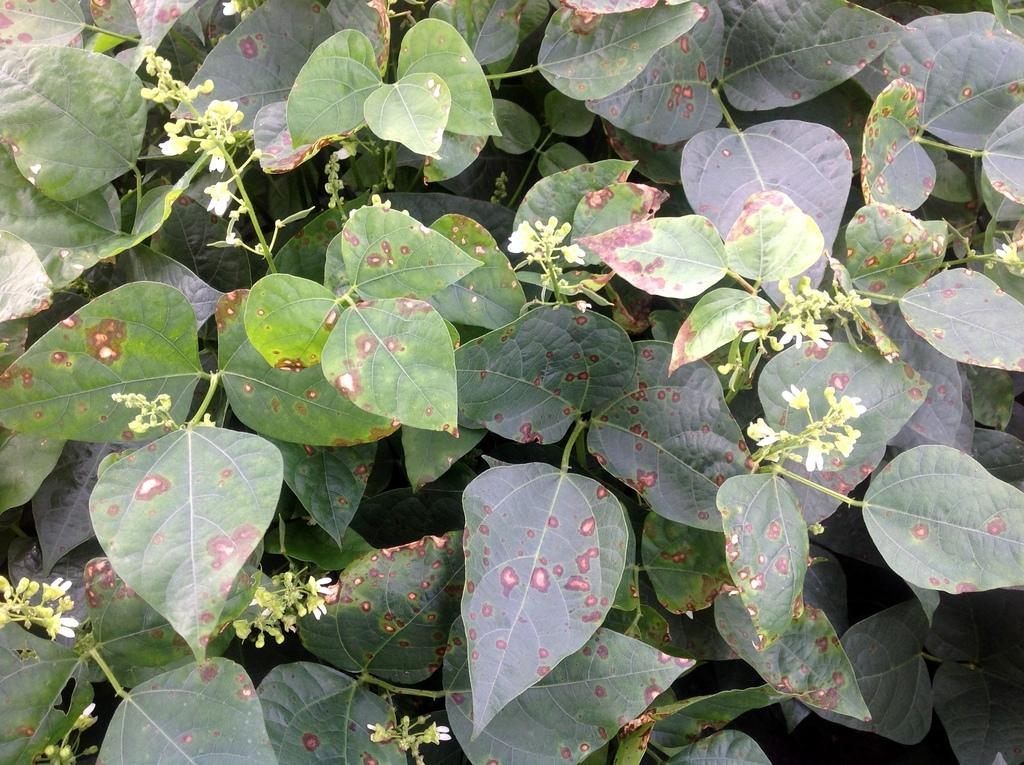What type of plant parts can be seen in the image? There are stems and leaves in the image. Can you describe the appearance of the stems? The stems are visible in the image, but their appearance cannot be determined without more information. What type of vegetation might these stems and leaves belong to? Without more context, it is impossible to determine the specific type of vegetation these stems and leaves belong to. How many times did the leaves kick the ball during the soccer game in the image? There is no soccer game or ball present in the image, so it is not possible to answer that question. 